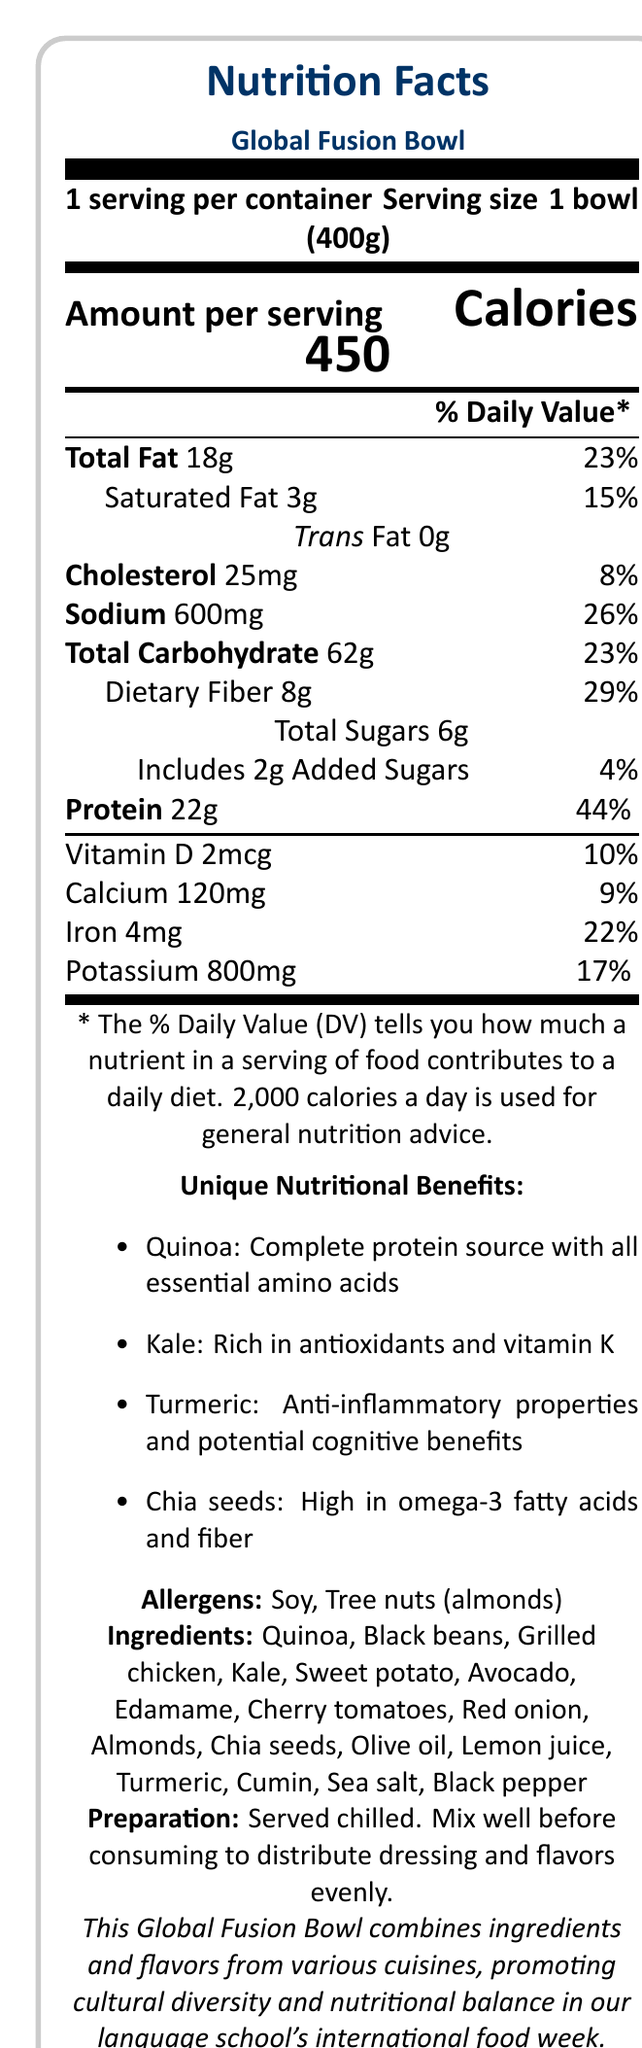what is the serving size of the Global Fusion Bowl? The serving size is clearly stated as "1 bowl (400g)" in the document.
Answer: 1 bowl (400g) how many calories are in one serving of the Global Fusion Bowl? The document indicates that one serving contains 450 calories.
Answer: 450 what is the percentage of daily value for dietary fiber in the Global Fusion Bowl? The document specifies that the dietary fiber content is 8g, which accounts for 29% of the daily value.
Answer: 29% which ingredient in the Global Fusion Bowl is noted for being high in omega-3 fatty acids and fiber? The document mentions that chia seeds are high in omega-3 fatty acids and fiber.
Answer: Chia seeds how much protein is in one serving of the Global Fusion Bowl? The document lists the protein content as 22g per serving.
Answer: 22g the Global Fusion Bowl is rich in various nutrients. Which one of the following nutrients has the highest daily value percentage? A. Saturated Fat B. Vitamin D C. Protein D. Sodium Protein has the highest daily value percentage at 44%, which is noted in the document.
Answer: C. Protein which of these ingredients is NOT listed in the Global Fusion Bowl? A. Broccoli B. Avocado C. Sweet potato D. Black beans The ingredients section lists avocado, sweet potato, and black beans, but not broccoli.
Answer: A. Broccoli does the Global Fusion Bowl contain any added sugars? The document shows that the Global Fusion Bowl contains 2g of added sugars.
Answer: Yes does the document mention kale as an ingredient? Kale is listed both in the unique nutritional benefits and ingredients sections.
Answer: Yes describe the main idea of the document The document is designed to inform consumers about the nutritional content and health benefits of the Global Fusion Bowl, as well as guide them on its ingredients and allergens.
Answer: The document presents the nutrition facts of the Global Fusion Bowl, including its serving size, caloric content, percentages of daily values for various nutrients, and unique nutritional benefits from specific ingredients. It highlights cultural diversity by combining ingredients from various cuisines and offers preparation instructions. The document also mentions allergens present in the dish. what is the dress code for the event where the Global Fusion Bowl will be served? The document does not provide any information about a dress code for the event.
Answer: Cannot be determined what is unique about the turmeric in the Global Fusion Bowl? The document specifies that turmeric has anti-inflammatory properties and potential cognitive benefits.
Answer: Anti-inflammatory properties and potential cognitive benefits what is the daily value percentage of iron provided by the Global Fusion Bowl? The document states that the Global Fusion Bowl contains 4mg of iron, which accounts for 22% of the daily value.
Answer: 22% what is the recommended preparation method for the Global Fusion Bowl? The preparation instructions clearly state that the dish should be served chilled and mixed well before consuming.
Answer: Served chilled. Mix well before consuming to distribute dressing and flavors evenly. is the Global Fusion Bowl free from all allergens? The document lists soy and tree nuts (almonds) as allergens present in the Global Fusion Bowl.
Answer: No 